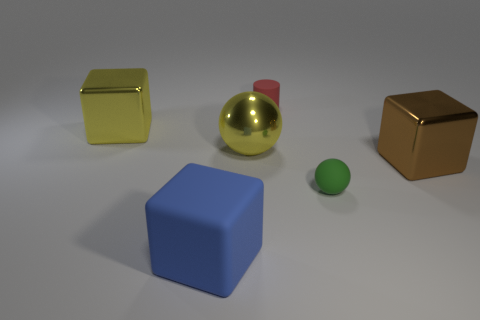Subtract all cyan blocks. Subtract all brown spheres. How many blocks are left? 3 Add 2 green balls. How many objects exist? 8 Subtract all cylinders. How many objects are left? 5 Add 3 big blue matte objects. How many big blue matte objects exist? 4 Subtract 0 brown spheres. How many objects are left? 6 Subtract all small green rubber things. Subtract all matte spheres. How many objects are left? 4 Add 2 large rubber objects. How many large rubber objects are left? 3 